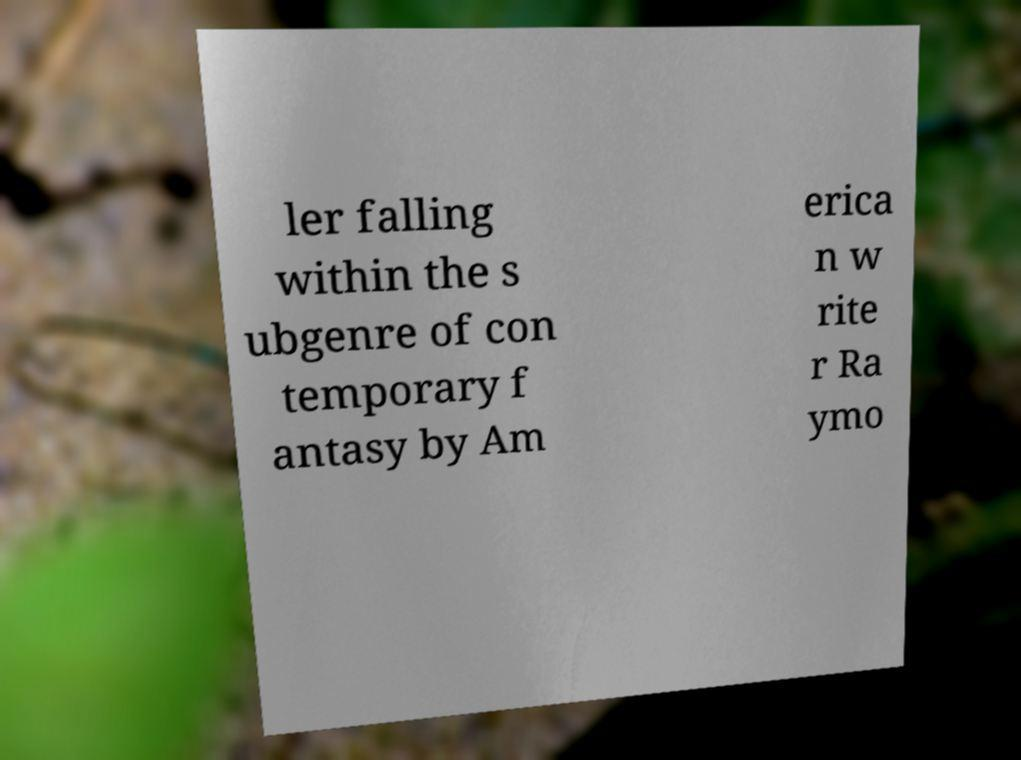There's text embedded in this image that I need extracted. Can you transcribe it verbatim? ler falling within the s ubgenre of con temporary f antasy by Am erica n w rite r Ra ymo 